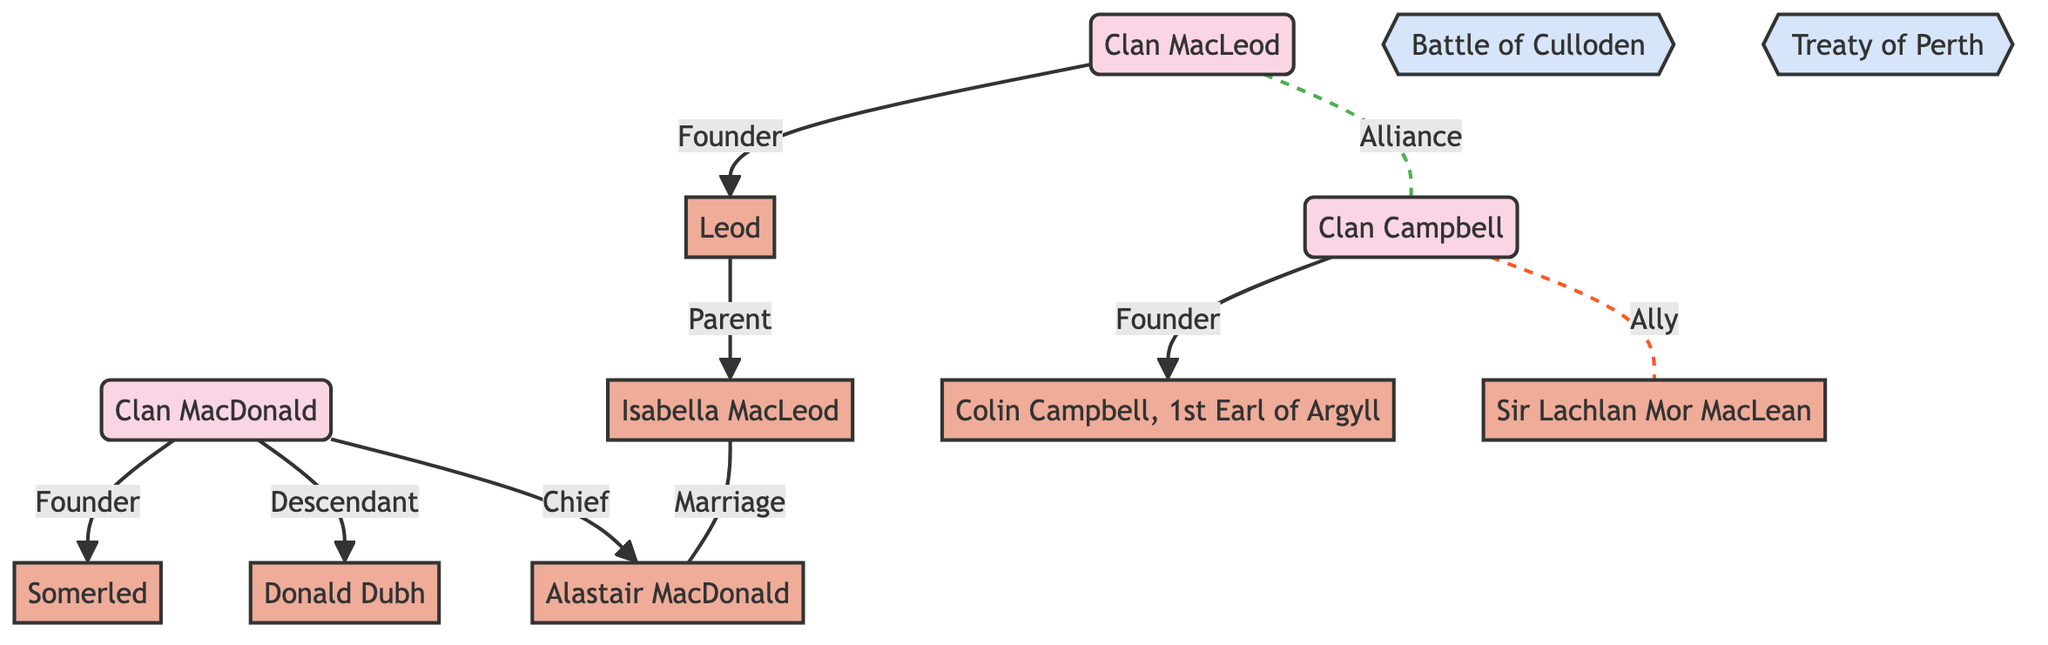What is the label of node 1? The label of node 1 is "Clan MacLeod" as represented in the diagram where it is listed first among clans.
Answer: Clan MacLeod Who is the founder of Clan Campbell? The founder of Clan Campbell is "Colin Campbell, 1st Earl of Argyll," which can be seen in the edge connecting node 2 to node 6 labeled "Founder."
Answer: Colin Campbell, 1st Earl of Argyll How many clans are represented in the diagram? There are three clans represented in the diagram, which are shown as distinct nodes labeled "Clan MacLeod," "Clan Campbell," and "Clan MacDonald."
Answer: 3 What type of relationship exists between Clan MacDonald and Donald Dubh? The relationship type is "Descendant," as indicated by the edge connecting node 3 (Clan MacDonald) to node 9 (Donald Dubh) labeled as such.
Answer: Descendant Which two clans are connected by an alliance during the Treaty of Perth? The two clans are Clan MacLeod (node 1) and Clan Campbell (node 2), represented by the edge labeled "Alliance" and associated with the event "Treaty of Perth."
Answer: Clan MacLeod and Clan Campbell Who is the parent of Isabella MacLeod? The parent of Isabella MacLeod is "Leod," as indicated by the edge connecting node 4 (Leod) to node 10 (Isabella MacLeod) labeled "Parent."
Answer: Leod What is the event associated with the alliance between Clan MacLeod and Clan Campbell? The event associated with the alliance is the "Treaty of Perth," as indicated in the edge connecting the two clans with a note about the event.
Answer: Treaty of Perth Which member is listed as the chief of Clan MacDonald? The chief of Clan MacDonald is "Alastair MacDonald," as shown in the edge connecting node 3 (Clan MacDonald) to node 8 (Alastair MacDonald) labeled "Chief."
Answer: Alastair MacDonald In which historical event are Clan Campbell and Sir Lachlan Mor MacLean allies? The historical event is the "Battle of Culloden," as indicated by the edge connecting Clan Campbell to Sir Lachlan Mor MacLean, labeled "Ally" with a note pertaining to the event.
Answer: Battle of Culloden 